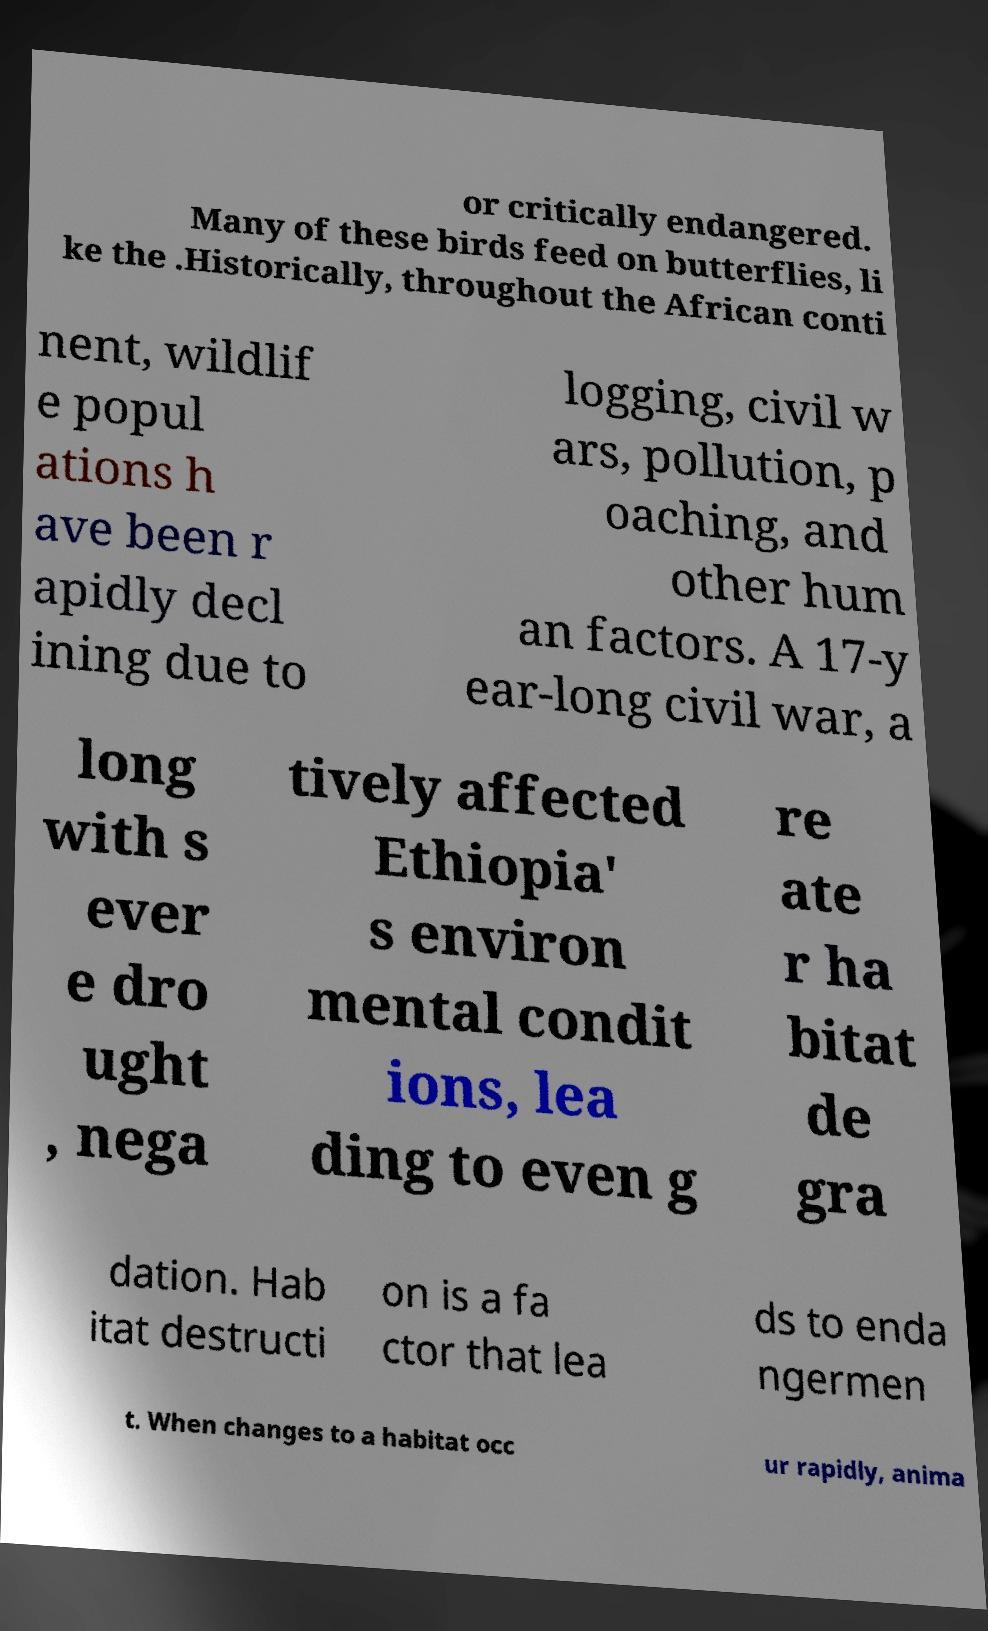Can you read and provide the text displayed in the image?This photo seems to have some interesting text. Can you extract and type it out for me? or critically endangered. Many of these birds feed on butterflies, li ke the .Historically, throughout the African conti nent, wildlif e popul ations h ave been r apidly decl ining due to logging, civil w ars, pollution, p oaching, and other hum an factors. A 17-y ear-long civil war, a long with s ever e dro ught , nega tively affected Ethiopia' s environ mental condit ions, lea ding to even g re ate r ha bitat de gra dation. Hab itat destructi on is a fa ctor that lea ds to enda ngermen t. When changes to a habitat occ ur rapidly, anima 